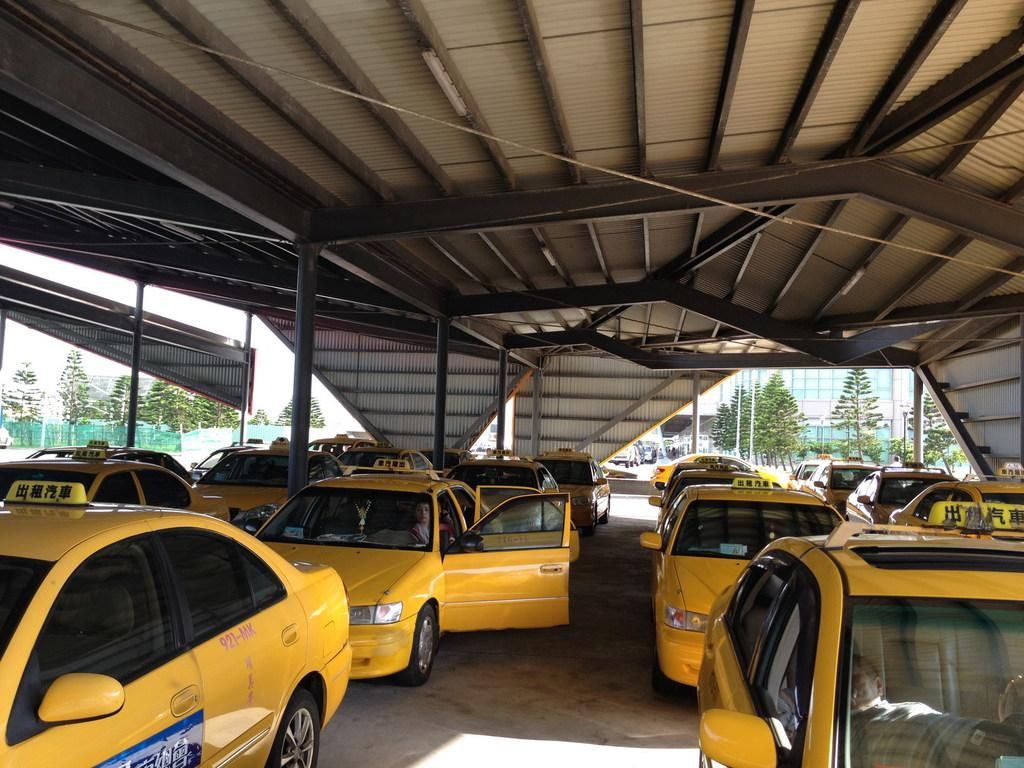What color are the cars in the image? The cars in the image are yellow. Where are the cars located in the image? The cars are on the ground. What can be seen in the background of the image? In the background of the image, there are poles, buildings, trees, a fence, and other objects. What part of the natural environment is visible in the image? The sky is visible in the background of the image. What angle does the achiever use to crack the code in the image? There is no mention of an achiever or a code in the image; it features yellow cars on the ground with various background elements. 